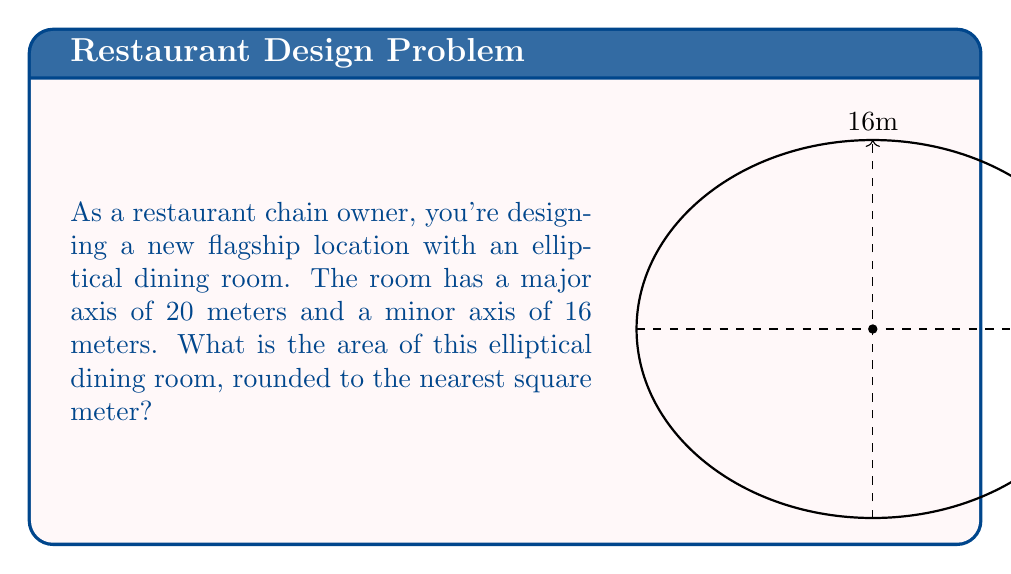Provide a solution to this math problem. To find the area of an elliptical dining room, we'll use the formula for the area of an ellipse:

$$A = \pi ab$$

Where:
$A$ = area of the ellipse
$a$ = length of the semi-major axis (half of the major axis)
$b$ = length of the semi-minor axis (half of the minor axis)

Given:
- Major axis = 20 meters
- Minor axis = 16 meters

Step 1: Calculate the semi-major and semi-minor axes
$a = 20 \div 2 = 10$ meters
$b = 16 \div 2 = 8$ meters

Step 2: Apply the area formula
$$A = \pi ab$$
$$A = \pi (10)(8)$$
$$A = 80\pi$$

Step 3: Calculate and round to the nearest square meter
$$A \approx 80 \times 3.14159 \approx 251.327$$

Rounding to the nearest square meter: 251 m²
Answer: 251 m² 